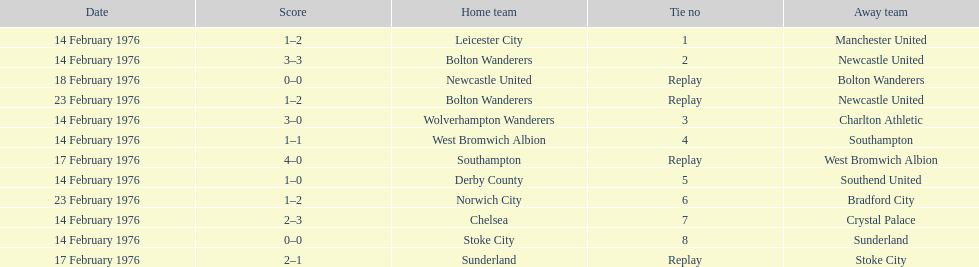How many of these games occurred before 17 february 1976? 7. 